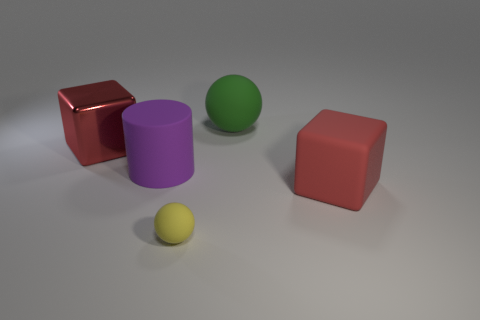The object that is behind the large red block that is behind the cube that is in front of the large metal block is made of what material?
Make the answer very short. Rubber. Do the green object and the matte cylinder have the same size?
Offer a terse response. Yes. What is the small yellow ball made of?
Your answer should be very brief. Rubber. There is a large object that is the same color as the metallic cube; what material is it?
Make the answer very short. Rubber. Do the big red thing that is behind the big purple rubber cylinder and the large green object have the same shape?
Your response must be concise. No. How many objects are yellow matte cylinders or large green rubber spheres?
Ensure brevity in your answer.  1. Does the red thing that is on the right side of the purple object have the same material as the green object?
Ensure brevity in your answer.  Yes. The purple rubber cylinder is what size?
Make the answer very short. Large. The large rubber object that is the same color as the big metallic block is what shape?
Offer a terse response. Cube. What number of cylinders are rubber things or large green things?
Your answer should be very brief. 1. 